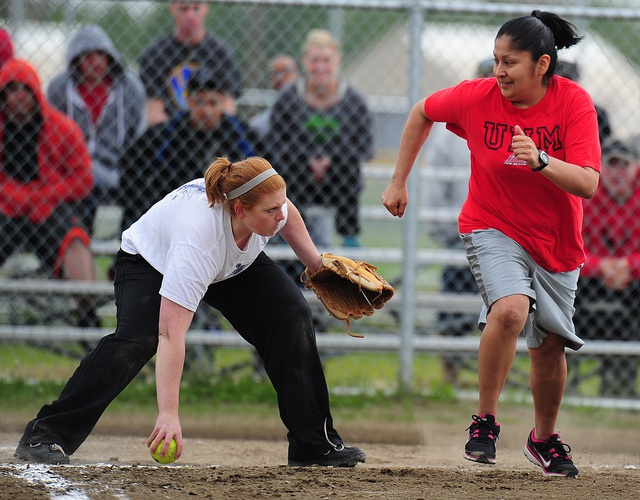Describe the objects in this image and their specific colors. I can see people in darkgreen, black, lavender, darkgray, and gray tones, people in darkgreen, brown, maroon, and black tones, people in darkgreen, black, brown, maroon, and gray tones, people in darkgreen, black, gray, and darkgray tones, and people in darkgreen, black, gray, and brown tones in this image. 